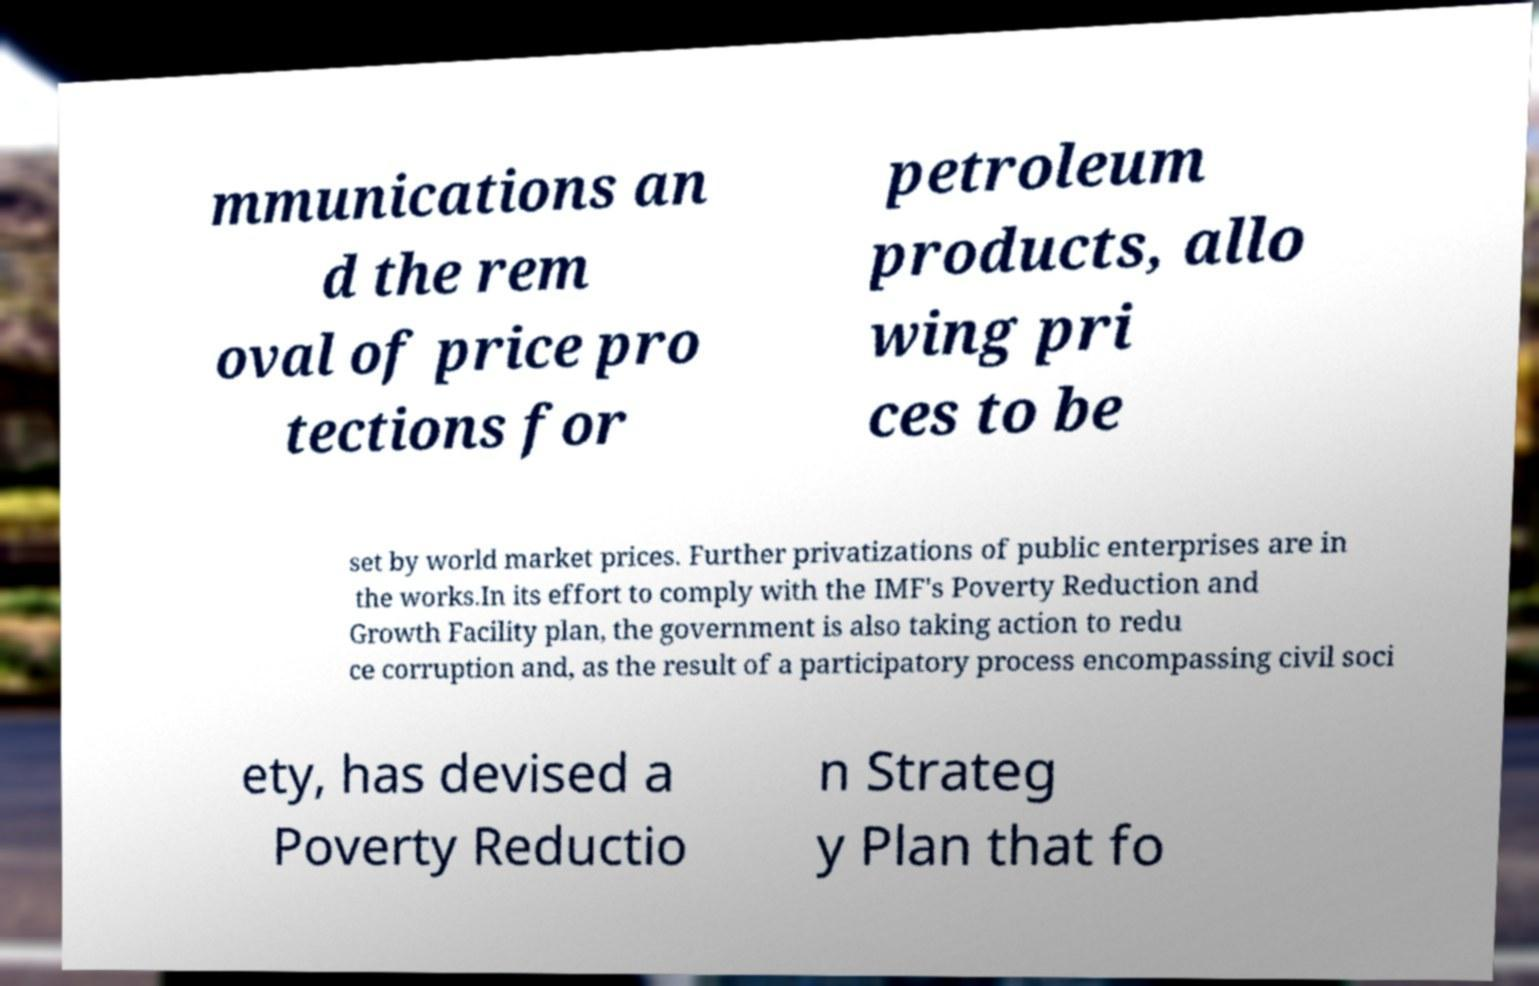What messages or text are displayed in this image? I need them in a readable, typed format. mmunications an d the rem oval of price pro tections for petroleum products, allo wing pri ces to be set by world market prices. Further privatizations of public enterprises are in the works.In its effort to comply with the IMF's Poverty Reduction and Growth Facility plan, the government is also taking action to redu ce corruption and, as the result of a participatory process encompassing civil soci ety, has devised a Poverty Reductio n Strateg y Plan that fo 